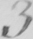What is written in this line of handwriting? 3 . 